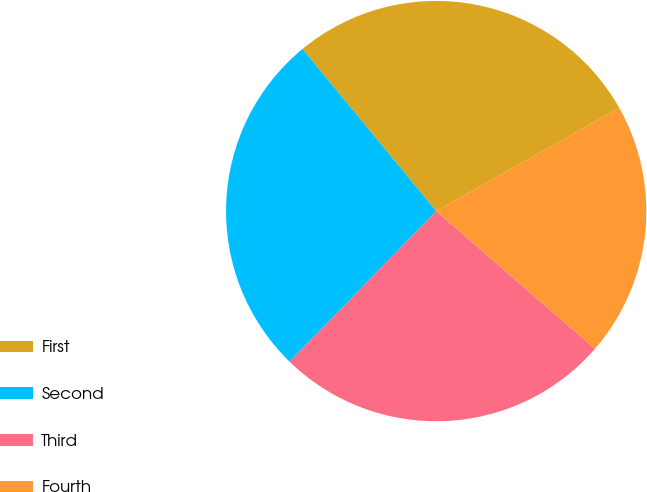Convert chart to OTSL. <chart><loc_0><loc_0><loc_500><loc_500><pie_chart><fcel>First<fcel>Second<fcel>Third<fcel>Fourth<nl><fcel>27.8%<fcel>26.74%<fcel>25.91%<fcel>19.55%<nl></chart> 